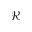Convert formula to latex. <formula><loc_0><loc_0><loc_500><loc_500>\mathcal { R }</formula> 